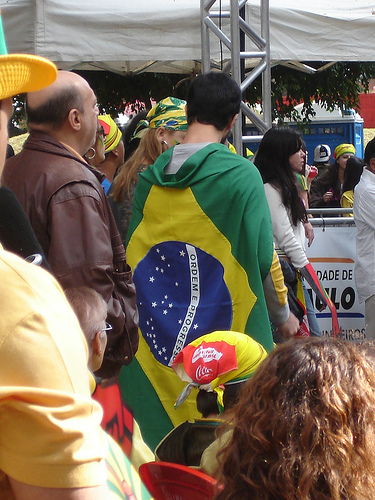<image>
Can you confirm if the flag is on the toilet? No. The flag is not positioned on the toilet. They may be near each other, but the flag is not supported by or resting on top of the toilet. 